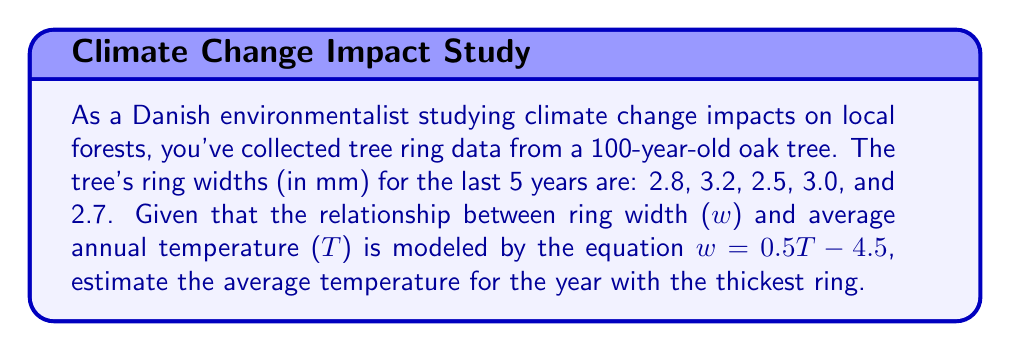Give your solution to this math problem. To solve this problem, we'll follow these steps:

1. Identify the thickest ring from the given data:
   The thickest ring is 3.2 mm wide.

2. Use the given equation to relate ring width to temperature:
   $w = 0.5T - 4.5$

3. Substitute the known ring width (w) into the equation:
   $3.2 = 0.5T - 4.5$

4. Solve for T (temperature):
   $3.2 + 4.5 = 0.5T$
   $7.7 = 0.5T$
   $T = 7.7 / 0.5 = 15.4$

Therefore, the estimated average temperature for the year with the thickest ring is 15.4°C.
Answer: 15.4°C 